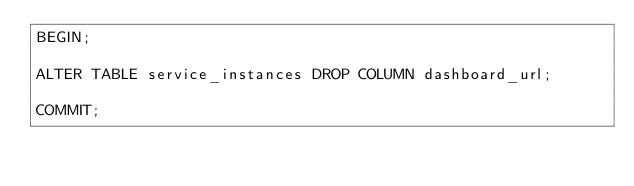<code> <loc_0><loc_0><loc_500><loc_500><_SQL_>BEGIN;

ALTER TABLE service_instances DROP COLUMN dashboard_url;

COMMIT;</code> 